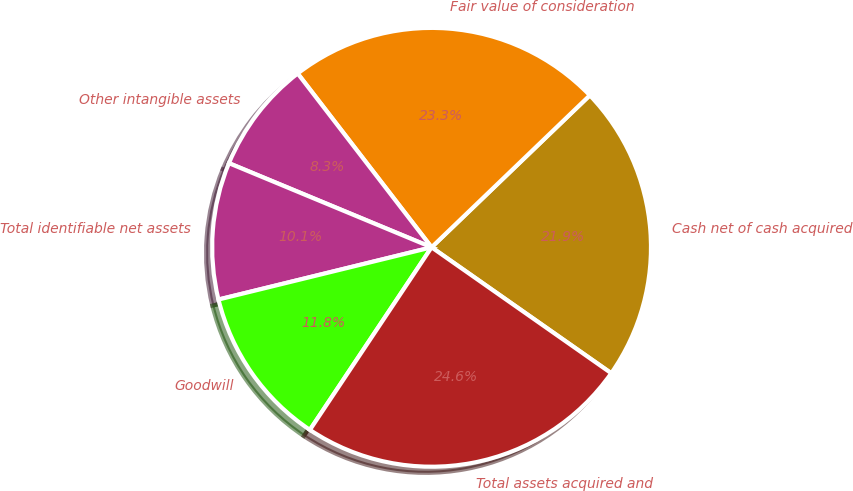Convert chart to OTSL. <chart><loc_0><loc_0><loc_500><loc_500><pie_chart><fcel>Cash net of cash acquired<fcel>Fair value of consideration<fcel>Other intangible assets<fcel>Total identifiable net assets<fcel>Goodwill<fcel>Total assets acquired and<nl><fcel>21.91%<fcel>23.27%<fcel>8.29%<fcel>10.09%<fcel>11.82%<fcel>24.63%<nl></chart> 